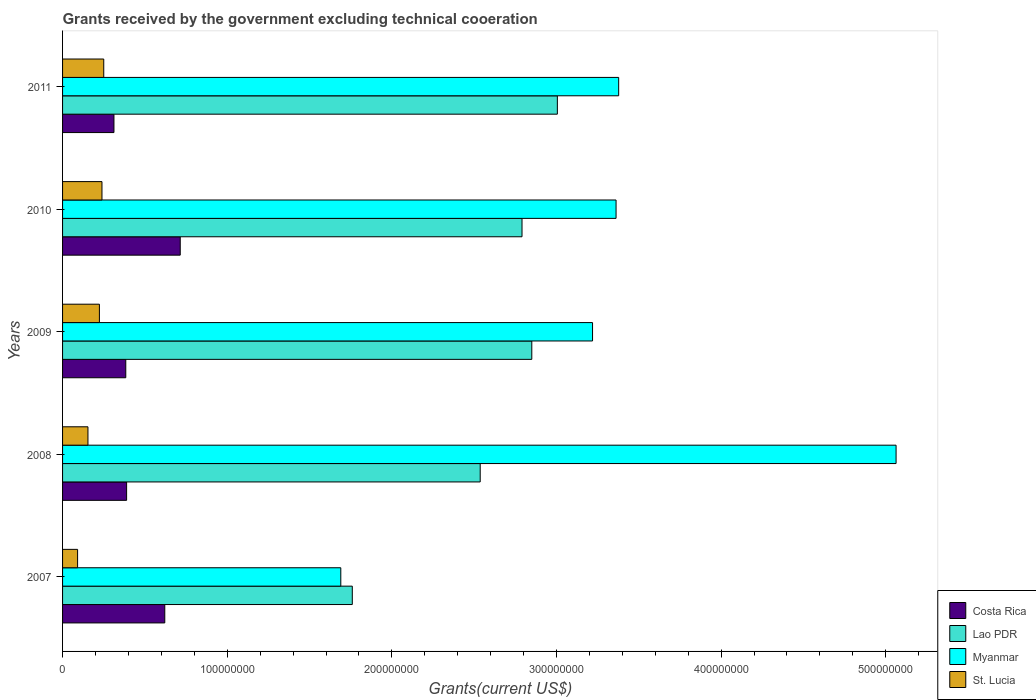How many different coloured bars are there?
Your response must be concise. 4. Are the number of bars per tick equal to the number of legend labels?
Provide a succinct answer. Yes. Are the number of bars on each tick of the Y-axis equal?
Your answer should be very brief. Yes. How many bars are there on the 3rd tick from the bottom?
Provide a succinct answer. 4. In how many cases, is the number of bars for a given year not equal to the number of legend labels?
Your answer should be very brief. 0. What is the total grants received by the government in Costa Rica in 2008?
Your answer should be very brief. 3.89e+07. Across all years, what is the maximum total grants received by the government in Costa Rica?
Give a very brief answer. 7.15e+07. Across all years, what is the minimum total grants received by the government in Lao PDR?
Keep it short and to the point. 1.76e+08. In which year was the total grants received by the government in Lao PDR minimum?
Offer a terse response. 2007. What is the total total grants received by the government in Myanmar in the graph?
Your answer should be compact. 1.67e+09. What is the difference between the total grants received by the government in Lao PDR in 2007 and that in 2008?
Your response must be concise. -7.77e+07. What is the difference between the total grants received by the government in St. Lucia in 2010 and the total grants received by the government in Myanmar in 2009?
Ensure brevity in your answer.  -2.98e+08. What is the average total grants received by the government in Myanmar per year?
Your response must be concise. 3.34e+08. In the year 2007, what is the difference between the total grants received by the government in Myanmar and total grants received by the government in Costa Rica?
Your answer should be compact. 1.07e+08. What is the ratio of the total grants received by the government in Myanmar in 2007 to that in 2010?
Make the answer very short. 0.5. Is the total grants received by the government in St. Lucia in 2009 less than that in 2010?
Offer a terse response. Yes. What is the difference between the highest and the second highest total grants received by the government in Costa Rica?
Give a very brief answer. 9.39e+06. What is the difference between the highest and the lowest total grants received by the government in Costa Rica?
Your response must be concise. 4.03e+07. In how many years, is the total grants received by the government in Lao PDR greater than the average total grants received by the government in Lao PDR taken over all years?
Provide a succinct answer. 3. Is the sum of the total grants received by the government in Lao PDR in 2007 and 2009 greater than the maximum total grants received by the government in St. Lucia across all years?
Give a very brief answer. Yes. What does the 1st bar from the top in 2008 represents?
Give a very brief answer. St. Lucia. What does the 4th bar from the bottom in 2008 represents?
Provide a short and direct response. St. Lucia. Is it the case that in every year, the sum of the total grants received by the government in St. Lucia and total grants received by the government in Myanmar is greater than the total grants received by the government in Costa Rica?
Your answer should be compact. Yes. How many years are there in the graph?
Make the answer very short. 5. What is the difference between two consecutive major ticks on the X-axis?
Offer a very short reply. 1.00e+08. Does the graph contain any zero values?
Your response must be concise. No. Does the graph contain grids?
Give a very brief answer. No. How many legend labels are there?
Ensure brevity in your answer.  4. What is the title of the graph?
Provide a succinct answer. Grants received by the government excluding technical cooeration. Does "Japan" appear as one of the legend labels in the graph?
Give a very brief answer. No. What is the label or title of the X-axis?
Give a very brief answer. Grants(current US$). What is the Grants(current US$) in Costa Rica in 2007?
Ensure brevity in your answer.  6.21e+07. What is the Grants(current US$) in Lao PDR in 2007?
Provide a short and direct response. 1.76e+08. What is the Grants(current US$) in Myanmar in 2007?
Offer a terse response. 1.69e+08. What is the Grants(current US$) in St. Lucia in 2007?
Provide a succinct answer. 9.13e+06. What is the Grants(current US$) in Costa Rica in 2008?
Keep it short and to the point. 3.89e+07. What is the Grants(current US$) in Lao PDR in 2008?
Give a very brief answer. 2.54e+08. What is the Grants(current US$) in Myanmar in 2008?
Make the answer very short. 5.06e+08. What is the Grants(current US$) in St. Lucia in 2008?
Make the answer very short. 1.54e+07. What is the Grants(current US$) of Costa Rica in 2009?
Ensure brevity in your answer.  3.84e+07. What is the Grants(current US$) in Lao PDR in 2009?
Provide a succinct answer. 2.85e+08. What is the Grants(current US$) of Myanmar in 2009?
Your answer should be very brief. 3.22e+08. What is the Grants(current US$) in St. Lucia in 2009?
Provide a short and direct response. 2.24e+07. What is the Grants(current US$) of Costa Rica in 2010?
Ensure brevity in your answer.  7.15e+07. What is the Grants(current US$) of Lao PDR in 2010?
Your response must be concise. 2.79e+08. What is the Grants(current US$) in Myanmar in 2010?
Provide a short and direct response. 3.36e+08. What is the Grants(current US$) of St. Lucia in 2010?
Give a very brief answer. 2.39e+07. What is the Grants(current US$) of Costa Rica in 2011?
Ensure brevity in your answer.  3.12e+07. What is the Grants(current US$) in Lao PDR in 2011?
Provide a short and direct response. 3.01e+08. What is the Grants(current US$) in Myanmar in 2011?
Your response must be concise. 3.38e+08. What is the Grants(current US$) in St. Lucia in 2011?
Keep it short and to the point. 2.50e+07. Across all years, what is the maximum Grants(current US$) in Costa Rica?
Your answer should be compact. 7.15e+07. Across all years, what is the maximum Grants(current US$) in Lao PDR?
Your answer should be very brief. 3.01e+08. Across all years, what is the maximum Grants(current US$) of Myanmar?
Ensure brevity in your answer.  5.06e+08. Across all years, what is the maximum Grants(current US$) in St. Lucia?
Give a very brief answer. 2.50e+07. Across all years, what is the minimum Grants(current US$) of Costa Rica?
Ensure brevity in your answer.  3.12e+07. Across all years, what is the minimum Grants(current US$) in Lao PDR?
Provide a short and direct response. 1.76e+08. Across all years, what is the minimum Grants(current US$) in Myanmar?
Ensure brevity in your answer.  1.69e+08. Across all years, what is the minimum Grants(current US$) of St. Lucia?
Give a very brief answer. 9.13e+06. What is the total Grants(current US$) in Costa Rica in the graph?
Your response must be concise. 2.42e+08. What is the total Grants(current US$) in Lao PDR in the graph?
Offer a very short reply. 1.29e+09. What is the total Grants(current US$) of Myanmar in the graph?
Ensure brevity in your answer.  1.67e+09. What is the total Grants(current US$) of St. Lucia in the graph?
Offer a very short reply. 9.59e+07. What is the difference between the Grants(current US$) in Costa Rica in 2007 and that in 2008?
Provide a succinct answer. 2.32e+07. What is the difference between the Grants(current US$) of Lao PDR in 2007 and that in 2008?
Provide a short and direct response. -7.77e+07. What is the difference between the Grants(current US$) of Myanmar in 2007 and that in 2008?
Your answer should be very brief. -3.37e+08. What is the difference between the Grants(current US$) in St. Lucia in 2007 and that in 2008?
Offer a terse response. -6.29e+06. What is the difference between the Grants(current US$) in Costa Rica in 2007 and that in 2009?
Offer a terse response. 2.37e+07. What is the difference between the Grants(current US$) in Lao PDR in 2007 and that in 2009?
Offer a very short reply. -1.09e+08. What is the difference between the Grants(current US$) of Myanmar in 2007 and that in 2009?
Your answer should be compact. -1.53e+08. What is the difference between the Grants(current US$) in St. Lucia in 2007 and that in 2009?
Give a very brief answer. -1.32e+07. What is the difference between the Grants(current US$) in Costa Rica in 2007 and that in 2010?
Your answer should be very brief. -9.39e+06. What is the difference between the Grants(current US$) of Lao PDR in 2007 and that in 2010?
Your response must be concise. -1.03e+08. What is the difference between the Grants(current US$) in Myanmar in 2007 and that in 2010?
Ensure brevity in your answer.  -1.67e+08. What is the difference between the Grants(current US$) of St. Lucia in 2007 and that in 2010?
Your answer should be compact. -1.48e+07. What is the difference between the Grants(current US$) in Costa Rica in 2007 and that in 2011?
Provide a succinct answer. 3.09e+07. What is the difference between the Grants(current US$) of Lao PDR in 2007 and that in 2011?
Your response must be concise. -1.25e+08. What is the difference between the Grants(current US$) of Myanmar in 2007 and that in 2011?
Your answer should be compact. -1.69e+08. What is the difference between the Grants(current US$) of St. Lucia in 2007 and that in 2011?
Offer a very short reply. -1.59e+07. What is the difference between the Grants(current US$) in Costa Rica in 2008 and that in 2009?
Your answer should be very brief. 5.00e+05. What is the difference between the Grants(current US$) of Lao PDR in 2008 and that in 2009?
Your response must be concise. -3.13e+07. What is the difference between the Grants(current US$) of Myanmar in 2008 and that in 2009?
Give a very brief answer. 1.84e+08. What is the difference between the Grants(current US$) of St. Lucia in 2008 and that in 2009?
Offer a very short reply. -6.96e+06. What is the difference between the Grants(current US$) in Costa Rica in 2008 and that in 2010?
Offer a terse response. -3.26e+07. What is the difference between the Grants(current US$) of Lao PDR in 2008 and that in 2010?
Offer a very short reply. -2.54e+07. What is the difference between the Grants(current US$) of Myanmar in 2008 and that in 2010?
Offer a very short reply. 1.70e+08. What is the difference between the Grants(current US$) of St. Lucia in 2008 and that in 2010?
Offer a terse response. -8.51e+06. What is the difference between the Grants(current US$) in Costa Rica in 2008 and that in 2011?
Offer a terse response. 7.69e+06. What is the difference between the Grants(current US$) of Lao PDR in 2008 and that in 2011?
Offer a very short reply. -4.69e+07. What is the difference between the Grants(current US$) in Myanmar in 2008 and that in 2011?
Provide a succinct answer. 1.68e+08. What is the difference between the Grants(current US$) of St. Lucia in 2008 and that in 2011?
Offer a very short reply. -9.59e+06. What is the difference between the Grants(current US$) in Costa Rica in 2009 and that in 2010?
Make the answer very short. -3.31e+07. What is the difference between the Grants(current US$) in Lao PDR in 2009 and that in 2010?
Your response must be concise. 5.94e+06. What is the difference between the Grants(current US$) in Myanmar in 2009 and that in 2010?
Provide a succinct answer. -1.43e+07. What is the difference between the Grants(current US$) of St. Lucia in 2009 and that in 2010?
Offer a very short reply. -1.55e+06. What is the difference between the Grants(current US$) in Costa Rica in 2009 and that in 2011?
Provide a short and direct response. 7.19e+06. What is the difference between the Grants(current US$) in Lao PDR in 2009 and that in 2011?
Keep it short and to the point. -1.55e+07. What is the difference between the Grants(current US$) in Myanmar in 2009 and that in 2011?
Your response must be concise. -1.59e+07. What is the difference between the Grants(current US$) of St. Lucia in 2009 and that in 2011?
Provide a succinct answer. -2.63e+06. What is the difference between the Grants(current US$) of Costa Rica in 2010 and that in 2011?
Provide a short and direct response. 4.03e+07. What is the difference between the Grants(current US$) of Lao PDR in 2010 and that in 2011?
Ensure brevity in your answer.  -2.15e+07. What is the difference between the Grants(current US$) in Myanmar in 2010 and that in 2011?
Provide a succinct answer. -1.59e+06. What is the difference between the Grants(current US$) of St. Lucia in 2010 and that in 2011?
Ensure brevity in your answer.  -1.08e+06. What is the difference between the Grants(current US$) of Costa Rica in 2007 and the Grants(current US$) of Lao PDR in 2008?
Your answer should be very brief. -1.92e+08. What is the difference between the Grants(current US$) of Costa Rica in 2007 and the Grants(current US$) of Myanmar in 2008?
Provide a short and direct response. -4.44e+08. What is the difference between the Grants(current US$) of Costa Rica in 2007 and the Grants(current US$) of St. Lucia in 2008?
Provide a succinct answer. 4.67e+07. What is the difference between the Grants(current US$) in Lao PDR in 2007 and the Grants(current US$) in Myanmar in 2008?
Your answer should be very brief. -3.30e+08. What is the difference between the Grants(current US$) of Lao PDR in 2007 and the Grants(current US$) of St. Lucia in 2008?
Your response must be concise. 1.61e+08. What is the difference between the Grants(current US$) of Myanmar in 2007 and the Grants(current US$) of St. Lucia in 2008?
Your answer should be compact. 1.54e+08. What is the difference between the Grants(current US$) in Costa Rica in 2007 and the Grants(current US$) in Lao PDR in 2009?
Offer a terse response. -2.23e+08. What is the difference between the Grants(current US$) in Costa Rica in 2007 and the Grants(current US$) in Myanmar in 2009?
Make the answer very short. -2.60e+08. What is the difference between the Grants(current US$) in Costa Rica in 2007 and the Grants(current US$) in St. Lucia in 2009?
Provide a short and direct response. 3.97e+07. What is the difference between the Grants(current US$) in Lao PDR in 2007 and the Grants(current US$) in Myanmar in 2009?
Your response must be concise. -1.46e+08. What is the difference between the Grants(current US$) in Lao PDR in 2007 and the Grants(current US$) in St. Lucia in 2009?
Offer a very short reply. 1.54e+08. What is the difference between the Grants(current US$) of Myanmar in 2007 and the Grants(current US$) of St. Lucia in 2009?
Ensure brevity in your answer.  1.47e+08. What is the difference between the Grants(current US$) in Costa Rica in 2007 and the Grants(current US$) in Lao PDR in 2010?
Give a very brief answer. -2.17e+08. What is the difference between the Grants(current US$) of Costa Rica in 2007 and the Grants(current US$) of Myanmar in 2010?
Your answer should be very brief. -2.74e+08. What is the difference between the Grants(current US$) in Costa Rica in 2007 and the Grants(current US$) in St. Lucia in 2010?
Your response must be concise. 3.82e+07. What is the difference between the Grants(current US$) of Lao PDR in 2007 and the Grants(current US$) of Myanmar in 2010?
Provide a succinct answer. -1.60e+08. What is the difference between the Grants(current US$) of Lao PDR in 2007 and the Grants(current US$) of St. Lucia in 2010?
Make the answer very short. 1.52e+08. What is the difference between the Grants(current US$) of Myanmar in 2007 and the Grants(current US$) of St. Lucia in 2010?
Keep it short and to the point. 1.45e+08. What is the difference between the Grants(current US$) in Costa Rica in 2007 and the Grants(current US$) in Lao PDR in 2011?
Make the answer very short. -2.38e+08. What is the difference between the Grants(current US$) of Costa Rica in 2007 and the Grants(current US$) of Myanmar in 2011?
Give a very brief answer. -2.76e+08. What is the difference between the Grants(current US$) of Costa Rica in 2007 and the Grants(current US$) of St. Lucia in 2011?
Offer a terse response. 3.71e+07. What is the difference between the Grants(current US$) in Lao PDR in 2007 and the Grants(current US$) in Myanmar in 2011?
Ensure brevity in your answer.  -1.62e+08. What is the difference between the Grants(current US$) in Lao PDR in 2007 and the Grants(current US$) in St. Lucia in 2011?
Give a very brief answer. 1.51e+08. What is the difference between the Grants(current US$) of Myanmar in 2007 and the Grants(current US$) of St. Lucia in 2011?
Offer a very short reply. 1.44e+08. What is the difference between the Grants(current US$) of Costa Rica in 2008 and the Grants(current US$) of Lao PDR in 2009?
Provide a succinct answer. -2.46e+08. What is the difference between the Grants(current US$) in Costa Rica in 2008 and the Grants(current US$) in Myanmar in 2009?
Provide a succinct answer. -2.83e+08. What is the difference between the Grants(current US$) in Costa Rica in 2008 and the Grants(current US$) in St. Lucia in 2009?
Offer a very short reply. 1.65e+07. What is the difference between the Grants(current US$) of Lao PDR in 2008 and the Grants(current US$) of Myanmar in 2009?
Make the answer very short. -6.82e+07. What is the difference between the Grants(current US$) of Lao PDR in 2008 and the Grants(current US$) of St. Lucia in 2009?
Keep it short and to the point. 2.31e+08. What is the difference between the Grants(current US$) in Myanmar in 2008 and the Grants(current US$) in St. Lucia in 2009?
Offer a very short reply. 4.84e+08. What is the difference between the Grants(current US$) in Costa Rica in 2008 and the Grants(current US$) in Lao PDR in 2010?
Your response must be concise. -2.40e+08. What is the difference between the Grants(current US$) of Costa Rica in 2008 and the Grants(current US$) of Myanmar in 2010?
Make the answer very short. -2.97e+08. What is the difference between the Grants(current US$) of Costa Rica in 2008 and the Grants(current US$) of St. Lucia in 2010?
Offer a terse response. 1.50e+07. What is the difference between the Grants(current US$) of Lao PDR in 2008 and the Grants(current US$) of Myanmar in 2010?
Your answer should be compact. -8.25e+07. What is the difference between the Grants(current US$) of Lao PDR in 2008 and the Grants(current US$) of St. Lucia in 2010?
Your answer should be very brief. 2.30e+08. What is the difference between the Grants(current US$) of Myanmar in 2008 and the Grants(current US$) of St. Lucia in 2010?
Your answer should be compact. 4.82e+08. What is the difference between the Grants(current US$) in Costa Rica in 2008 and the Grants(current US$) in Lao PDR in 2011?
Keep it short and to the point. -2.62e+08. What is the difference between the Grants(current US$) in Costa Rica in 2008 and the Grants(current US$) in Myanmar in 2011?
Your answer should be very brief. -2.99e+08. What is the difference between the Grants(current US$) in Costa Rica in 2008 and the Grants(current US$) in St. Lucia in 2011?
Your answer should be very brief. 1.39e+07. What is the difference between the Grants(current US$) in Lao PDR in 2008 and the Grants(current US$) in Myanmar in 2011?
Offer a terse response. -8.41e+07. What is the difference between the Grants(current US$) in Lao PDR in 2008 and the Grants(current US$) in St. Lucia in 2011?
Make the answer very short. 2.29e+08. What is the difference between the Grants(current US$) of Myanmar in 2008 and the Grants(current US$) of St. Lucia in 2011?
Your response must be concise. 4.81e+08. What is the difference between the Grants(current US$) of Costa Rica in 2009 and the Grants(current US$) of Lao PDR in 2010?
Offer a terse response. -2.41e+08. What is the difference between the Grants(current US$) in Costa Rica in 2009 and the Grants(current US$) in Myanmar in 2010?
Your answer should be very brief. -2.98e+08. What is the difference between the Grants(current US$) of Costa Rica in 2009 and the Grants(current US$) of St. Lucia in 2010?
Offer a terse response. 1.45e+07. What is the difference between the Grants(current US$) of Lao PDR in 2009 and the Grants(current US$) of Myanmar in 2010?
Offer a very short reply. -5.12e+07. What is the difference between the Grants(current US$) in Lao PDR in 2009 and the Grants(current US$) in St. Lucia in 2010?
Provide a short and direct response. 2.61e+08. What is the difference between the Grants(current US$) in Myanmar in 2009 and the Grants(current US$) in St. Lucia in 2010?
Your response must be concise. 2.98e+08. What is the difference between the Grants(current US$) in Costa Rica in 2009 and the Grants(current US$) in Lao PDR in 2011?
Provide a succinct answer. -2.62e+08. What is the difference between the Grants(current US$) of Costa Rica in 2009 and the Grants(current US$) of Myanmar in 2011?
Make the answer very short. -2.99e+08. What is the difference between the Grants(current US$) in Costa Rica in 2009 and the Grants(current US$) in St. Lucia in 2011?
Provide a short and direct response. 1.34e+07. What is the difference between the Grants(current US$) in Lao PDR in 2009 and the Grants(current US$) in Myanmar in 2011?
Give a very brief answer. -5.28e+07. What is the difference between the Grants(current US$) in Lao PDR in 2009 and the Grants(current US$) in St. Lucia in 2011?
Ensure brevity in your answer.  2.60e+08. What is the difference between the Grants(current US$) in Myanmar in 2009 and the Grants(current US$) in St. Lucia in 2011?
Ensure brevity in your answer.  2.97e+08. What is the difference between the Grants(current US$) of Costa Rica in 2010 and the Grants(current US$) of Lao PDR in 2011?
Offer a very short reply. -2.29e+08. What is the difference between the Grants(current US$) of Costa Rica in 2010 and the Grants(current US$) of Myanmar in 2011?
Provide a succinct answer. -2.66e+08. What is the difference between the Grants(current US$) in Costa Rica in 2010 and the Grants(current US$) in St. Lucia in 2011?
Give a very brief answer. 4.65e+07. What is the difference between the Grants(current US$) in Lao PDR in 2010 and the Grants(current US$) in Myanmar in 2011?
Provide a short and direct response. -5.87e+07. What is the difference between the Grants(current US$) in Lao PDR in 2010 and the Grants(current US$) in St. Lucia in 2011?
Your answer should be very brief. 2.54e+08. What is the difference between the Grants(current US$) of Myanmar in 2010 and the Grants(current US$) of St. Lucia in 2011?
Offer a very short reply. 3.11e+08. What is the average Grants(current US$) in Costa Rica per year?
Offer a terse response. 4.84e+07. What is the average Grants(current US$) in Lao PDR per year?
Your answer should be compact. 2.59e+08. What is the average Grants(current US$) of Myanmar per year?
Provide a succinct answer. 3.34e+08. What is the average Grants(current US$) of St. Lucia per year?
Offer a terse response. 1.92e+07. In the year 2007, what is the difference between the Grants(current US$) of Costa Rica and Grants(current US$) of Lao PDR?
Ensure brevity in your answer.  -1.14e+08. In the year 2007, what is the difference between the Grants(current US$) of Costa Rica and Grants(current US$) of Myanmar?
Give a very brief answer. -1.07e+08. In the year 2007, what is the difference between the Grants(current US$) in Costa Rica and Grants(current US$) in St. Lucia?
Make the answer very short. 5.30e+07. In the year 2007, what is the difference between the Grants(current US$) in Lao PDR and Grants(current US$) in Myanmar?
Provide a succinct answer. 6.99e+06. In the year 2007, what is the difference between the Grants(current US$) in Lao PDR and Grants(current US$) in St. Lucia?
Your answer should be very brief. 1.67e+08. In the year 2007, what is the difference between the Grants(current US$) of Myanmar and Grants(current US$) of St. Lucia?
Provide a short and direct response. 1.60e+08. In the year 2008, what is the difference between the Grants(current US$) of Costa Rica and Grants(current US$) of Lao PDR?
Your answer should be very brief. -2.15e+08. In the year 2008, what is the difference between the Grants(current US$) in Costa Rica and Grants(current US$) in Myanmar?
Keep it short and to the point. -4.67e+08. In the year 2008, what is the difference between the Grants(current US$) of Costa Rica and Grants(current US$) of St. Lucia?
Offer a terse response. 2.35e+07. In the year 2008, what is the difference between the Grants(current US$) of Lao PDR and Grants(current US$) of Myanmar?
Provide a succinct answer. -2.53e+08. In the year 2008, what is the difference between the Grants(current US$) of Lao PDR and Grants(current US$) of St. Lucia?
Offer a terse response. 2.38e+08. In the year 2008, what is the difference between the Grants(current US$) of Myanmar and Grants(current US$) of St. Lucia?
Keep it short and to the point. 4.91e+08. In the year 2009, what is the difference between the Grants(current US$) of Costa Rica and Grants(current US$) of Lao PDR?
Offer a terse response. -2.47e+08. In the year 2009, what is the difference between the Grants(current US$) in Costa Rica and Grants(current US$) in Myanmar?
Keep it short and to the point. -2.84e+08. In the year 2009, what is the difference between the Grants(current US$) in Costa Rica and Grants(current US$) in St. Lucia?
Provide a short and direct response. 1.60e+07. In the year 2009, what is the difference between the Grants(current US$) of Lao PDR and Grants(current US$) of Myanmar?
Keep it short and to the point. -3.69e+07. In the year 2009, what is the difference between the Grants(current US$) of Lao PDR and Grants(current US$) of St. Lucia?
Keep it short and to the point. 2.63e+08. In the year 2009, what is the difference between the Grants(current US$) in Myanmar and Grants(current US$) in St. Lucia?
Provide a short and direct response. 3.00e+08. In the year 2010, what is the difference between the Grants(current US$) of Costa Rica and Grants(current US$) of Lao PDR?
Offer a terse response. -2.08e+08. In the year 2010, what is the difference between the Grants(current US$) in Costa Rica and Grants(current US$) in Myanmar?
Your response must be concise. -2.65e+08. In the year 2010, what is the difference between the Grants(current US$) in Costa Rica and Grants(current US$) in St. Lucia?
Provide a short and direct response. 4.75e+07. In the year 2010, what is the difference between the Grants(current US$) of Lao PDR and Grants(current US$) of Myanmar?
Offer a terse response. -5.71e+07. In the year 2010, what is the difference between the Grants(current US$) of Lao PDR and Grants(current US$) of St. Lucia?
Give a very brief answer. 2.55e+08. In the year 2010, what is the difference between the Grants(current US$) in Myanmar and Grants(current US$) in St. Lucia?
Your answer should be very brief. 3.12e+08. In the year 2011, what is the difference between the Grants(current US$) of Costa Rica and Grants(current US$) of Lao PDR?
Ensure brevity in your answer.  -2.69e+08. In the year 2011, what is the difference between the Grants(current US$) in Costa Rica and Grants(current US$) in Myanmar?
Your answer should be very brief. -3.07e+08. In the year 2011, what is the difference between the Grants(current US$) in Costa Rica and Grants(current US$) in St. Lucia?
Give a very brief answer. 6.20e+06. In the year 2011, what is the difference between the Grants(current US$) of Lao PDR and Grants(current US$) of Myanmar?
Offer a terse response. -3.72e+07. In the year 2011, what is the difference between the Grants(current US$) of Lao PDR and Grants(current US$) of St. Lucia?
Provide a short and direct response. 2.76e+08. In the year 2011, what is the difference between the Grants(current US$) of Myanmar and Grants(current US$) of St. Lucia?
Offer a terse response. 3.13e+08. What is the ratio of the Grants(current US$) in Costa Rica in 2007 to that in 2008?
Offer a terse response. 1.6. What is the ratio of the Grants(current US$) of Lao PDR in 2007 to that in 2008?
Ensure brevity in your answer.  0.69. What is the ratio of the Grants(current US$) of Myanmar in 2007 to that in 2008?
Your response must be concise. 0.33. What is the ratio of the Grants(current US$) of St. Lucia in 2007 to that in 2008?
Give a very brief answer. 0.59. What is the ratio of the Grants(current US$) in Costa Rica in 2007 to that in 2009?
Your response must be concise. 1.62. What is the ratio of the Grants(current US$) in Lao PDR in 2007 to that in 2009?
Offer a terse response. 0.62. What is the ratio of the Grants(current US$) in Myanmar in 2007 to that in 2009?
Your answer should be compact. 0.53. What is the ratio of the Grants(current US$) in St. Lucia in 2007 to that in 2009?
Make the answer very short. 0.41. What is the ratio of the Grants(current US$) of Costa Rica in 2007 to that in 2010?
Your answer should be compact. 0.87. What is the ratio of the Grants(current US$) of Lao PDR in 2007 to that in 2010?
Your answer should be compact. 0.63. What is the ratio of the Grants(current US$) in Myanmar in 2007 to that in 2010?
Your response must be concise. 0.5. What is the ratio of the Grants(current US$) in St. Lucia in 2007 to that in 2010?
Ensure brevity in your answer.  0.38. What is the ratio of the Grants(current US$) of Costa Rica in 2007 to that in 2011?
Ensure brevity in your answer.  1.99. What is the ratio of the Grants(current US$) in Lao PDR in 2007 to that in 2011?
Your answer should be compact. 0.59. What is the ratio of the Grants(current US$) of Myanmar in 2007 to that in 2011?
Offer a terse response. 0.5. What is the ratio of the Grants(current US$) in St. Lucia in 2007 to that in 2011?
Offer a terse response. 0.37. What is the ratio of the Grants(current US$) in Costa Rica in 2008 to that in 2009?
Your answer should be compact. 1.01. What is the ratio of the Grants(current US$) in Lao PDR in 2008 to that in 2009?
Provide a short and direct response. 0.89. What is the ratio of the Grants(current US$) in Myanmar in 2008 to that in 2009?
Make the answer very short. 1.57. What is the ratio of the Grants(current US$) in St. Lucia in 2008 to that in 2009?
Provide a succinct answer. 0.69. What is the ratio of the Grants(current US$) of Costa Rica in 2008 to that in 2010?
Offer a very short reply. 0.54. What is the ratio of the Grants(current US$) in Lao PDR in 2008 to that in 2010?
Provide a short and direct response. 0.91. What is the ratio of the Grants(current US$) in Myanmar in 2008 to that in 2010?
Provide a succinct answer. 1.51. What is the ratio of the Grants(current US$) in St. Lucia in 2008 to that in 2010?
Offer a terse response. 0.64. What is the ratio of the Grants(current US$) of Costa Rica in 2008 to that in 2011?
Provide a succinct answer. 1.25. What is the ratio of the Grants(current US$) in Lao PDR in 2008 to that in 2011?
Your answer should be compact. 0.84. What is the ratio of the Grants(current US$) in Myanmar in 2008 to that in 2011?
Offer a terse response. 1.5. What is the ratio of the Grants(current US$) of St. Lucia in 2008 to that in 2011?
Your answer should be compact. 0.62. What is the ratio of the Grants(current US$) of Costa Rica in 2009 to that in 2010?
Ensure brevity in your answer.  0.54. What is the ratio of the Grants(current US$) in Lao PDR in 2009 to that in 2010?
Make the answer very short. 1.02. What is the ratio of the Grants(current US$) in Myanmar in 2009 to that in 2010?
Provide a succinct answer. 0.96. What is the ratio of the Grants(current US$) in St. Lucia in 2009 to that in 2010?
Your answer should be compact. 0.94. What is the ratio of the Grants(current US$) in Costa Rica in 2009 to that in 2011?
Keep it short and to the point. 1.23. What is the ratio of the Grants(current US$) of Lao PDR in 2009 to that in 2011?
Your response must be concise. 0.95. What is the ratio of the Grants(current US$) of Myanmar in 2009 to that in 2011?
Provide a short and direct response. 0.95. What is the ratio of the Grants(current US$) of St. Lucia in 2009 to that in 2011?
Provide a short and direct response. 0.89. What is the ratio of the Grants(current US$) of Costa Rica in 2010 to that in 2011?
Provide a short and direct response. 2.29. What is the ratio of the Grants(current US$) in Myanmar in 2010 to that in 2011?
Give a very brief answer. 1. What is the ratio of the Grants(current US$) of St. Lucia in 2010 to that in 2011?
Your answer should be very brief. 0.96. What is the difference between the highest and the second highest Grants(current US$) of Costa Rica?
Offer a very short reply. 9.39e+06. What is the difference between the highest and the second highest Grants(current US$) of Lao PDR?
Make the answer very short. 1.55e+07. What is the difference between the highest and the second highest Grants(current US$) in Myanmar?
Make the answer very short. 1.68e+08. What is the difference between the highest and the second highest Grants(current US$) of St. Lucia?
Offer a terse response. 1.08e+06. What is the difference between the highest and the lowest Grants(current US$) in Costa Rica?
Offer a terse response. 4.03e+07. What is the difference between the highest and the lowest Grants(current US$) of Lao PDR?
Your answer should be very brief. 1.25e+08. What is the difference between the highest and the lowest Grants(current US$) of Myanmar?
Your response must be concise. 3.37e+08. What is the difference between the highest and the lowest Grants(current US$) of St. Lucia?
Provide a succinct answer. 1.59e+07. 